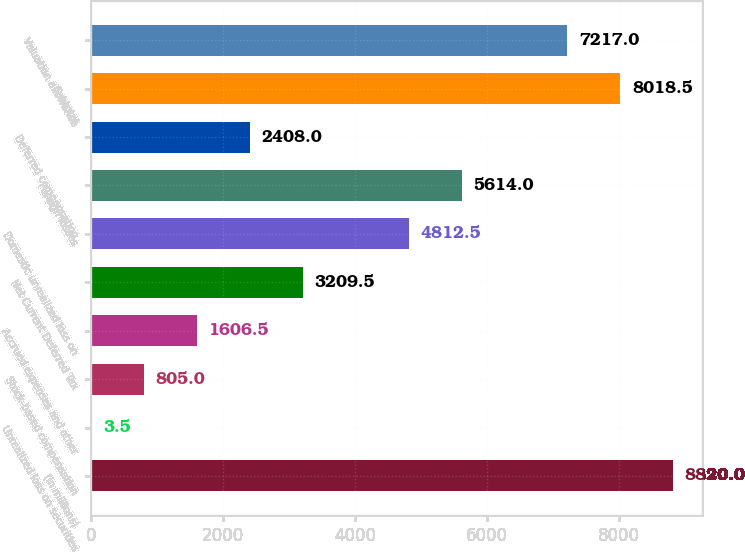<chart> <loc_0><loc_0><loc_500><loc_500><bar_chart><fcel>(in millions)<fcel>Unrealized loss on securities<fcel>Stock-based compensation<fcel>Accrued expenses and other<fcel>Net Current Deferred Tax<fcel>Domestic unrealized loss on<fcel>Foreign losses<fcel>Deferred compensation<fcel>Subtotal<fcel>Valuation allowance<nl><fcel>8820<fcel>3.5<fcel>805<fcel>1606.5<fcel>3209.5<fcel>4812.5<fcel>5614<fcel>2408<fcel>8018.5<fcel>7217<nl></chart> 